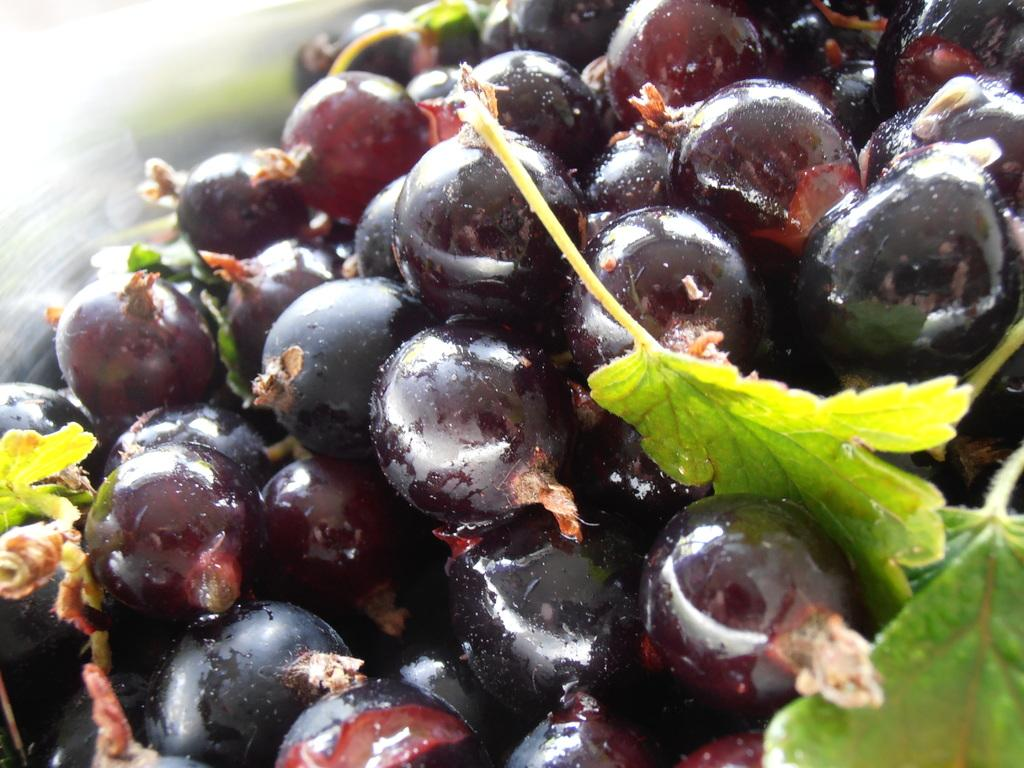What type of fruit is present in the image? There is a bunch of black grapes in the image. What else can be seen in the image besides the grapes? Leaves are visible in the image. What type of tool is being used to lift the grapes in the image? There is no tool or action of lifting the grapes in the image; they are simply hanging from a stem. 